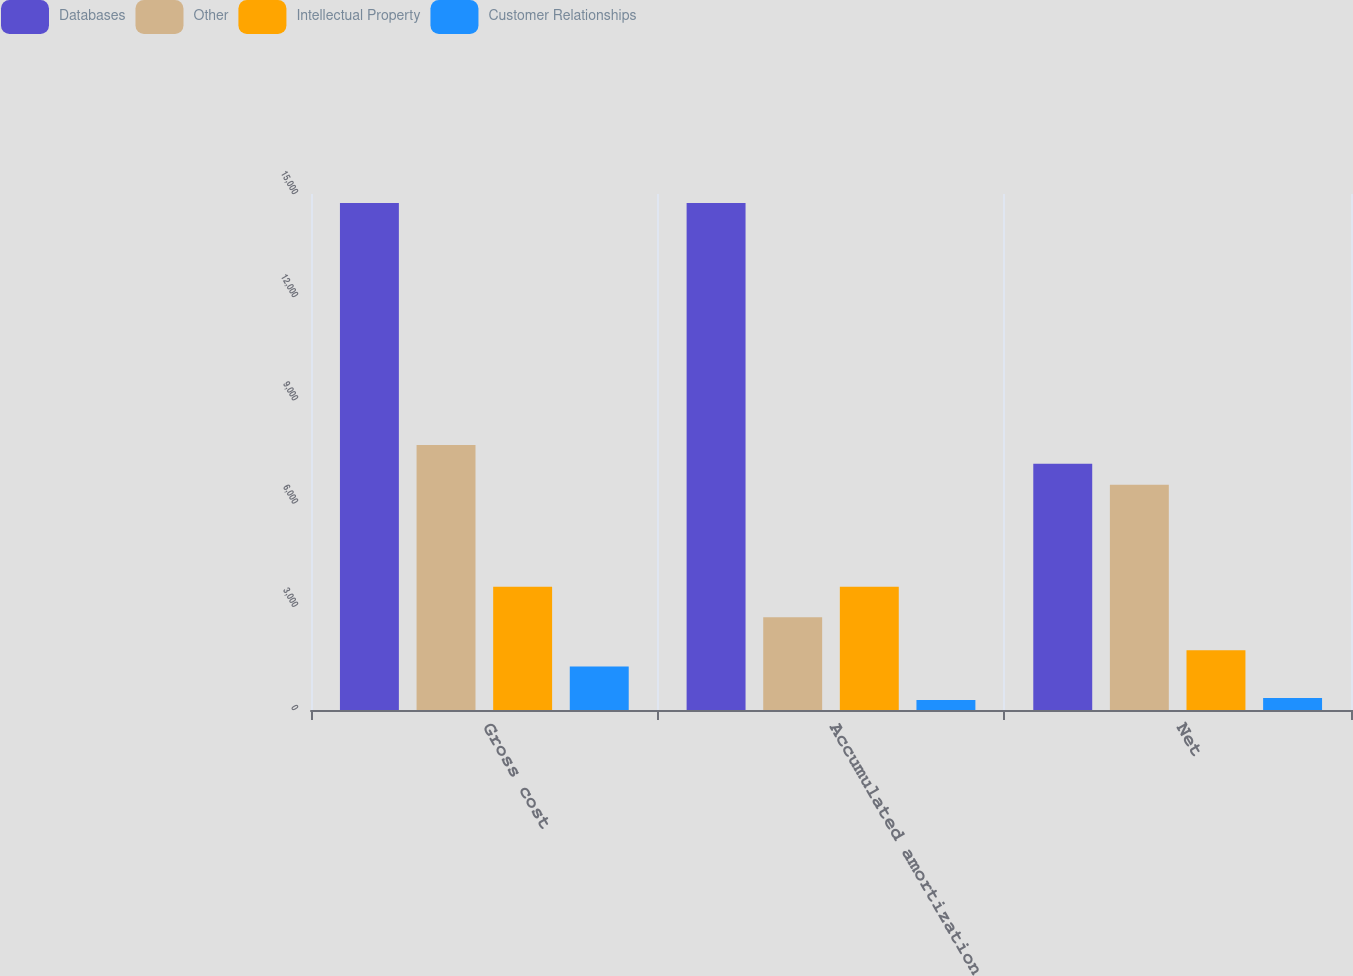Convert chart. <chart><loc_0><loc_0><loc_500><loc_500><stacked_bar_chart><ecel><fcel>Gross cost<fcel>Accumulated amortization<fcel>Net<nl><fcel>Databases<fcel>14741<fcel>14741<fcel>7159<nl><fcel>Other<fcel>7700<fcel>2695<fcel>6545<nl><fcel>Intellectual Property<fcel>3585<fcel>3585<fcel>1740<nl><fcel>Customer Relationships<fcel>1265<fcel>292<fcel>349<nl></chart> 